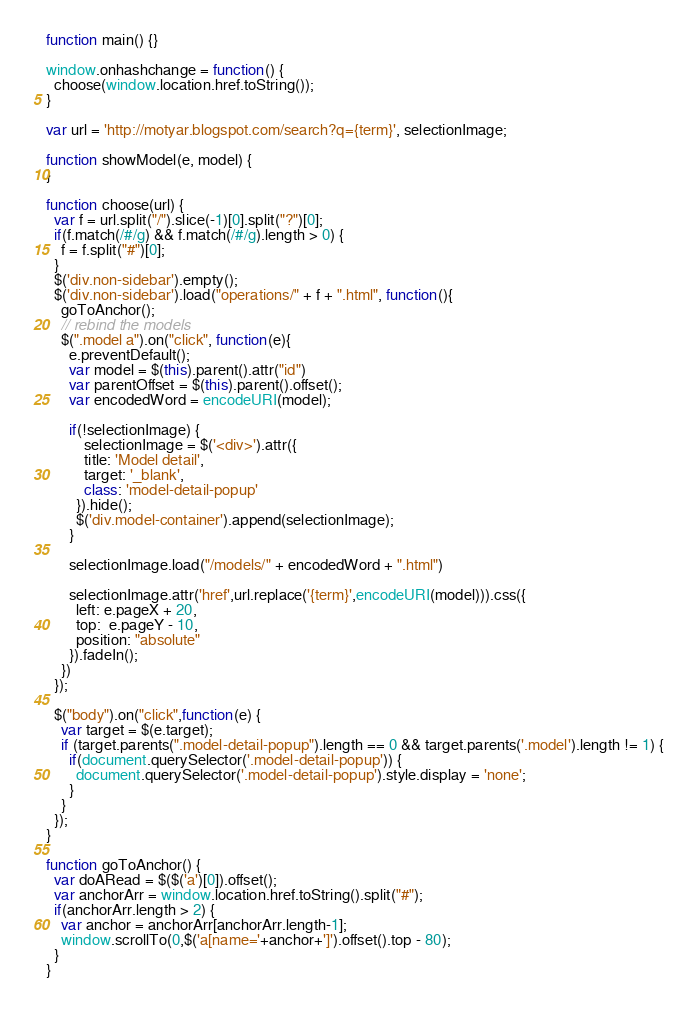<code> <loc_0><loc_0><loc_500><loc_500><_JavaScript_>function main() {}

window.onhashchange = function() {
  choose(window.location.href.toString());
}

var url = 'http://motyar.blogspot.com/search?q={term}', selectionImage;

function showModel(e, model) {
}

function choose(url) {
  var f = url.split("/").slice(-1)[0].split("?")[0];
  if(f.match(/#/g) && f.match(/#/g).length > 0) {
    f = f.split("#")[0];
  }
  $('div.non-sidebar').empty();
  $('div.non-sidebar').load("operations/" + f + ".html", function(){
    goToAnchor();
    // rebind the models
    $(".model a").on("click", function(e){
      e.preventDefault();
      var model = $(this).parent().attr("id")
      var parentOffset = $(this).parent().offset(); 
      var encodedWord = encodeURI(model);

      if(!selectionImage) {
          selectionImage = $('<div>').attr({
          title: 'Model detail',
          target: '_blank',
          class: 'model-detail-popup'
        }).hide();
        $('div.model-container').append(selectionImage);
      }

      selectionImage.load("/models/" + encodedWord + ".html")

      selectionImage.attr('href',url.replace('{term}',encodeURI(model))).css({
        left: e.pageX + 20,
        top:  e.pageY - 10,
        position: "absolute"
      }).fadeIn();
    })
  });

  $("body").on("click",function(e) {
    var target = $(e.target);
    if (target.parents(".model-detail-popup").length == 0 && target.parents('.model').length != 1) {
      if(document.querySelector('.model-detail-popup')) {
        document.querySelector('.model-detail-popup').style.display = 'none';
      }
    }
  });
}

function goToAnchor() {
  var doARead = $($('a')[0]).offset();
  var anchorArr = window.location.href.toString().split("#");
  if(anchorArr.length > 2) {
    var anchor = anchorArr[anchorArr.length-1];
    window.scrollTo(0,$('a[name='+anchor+']').offset().top - 80);
  }
}

</code> 